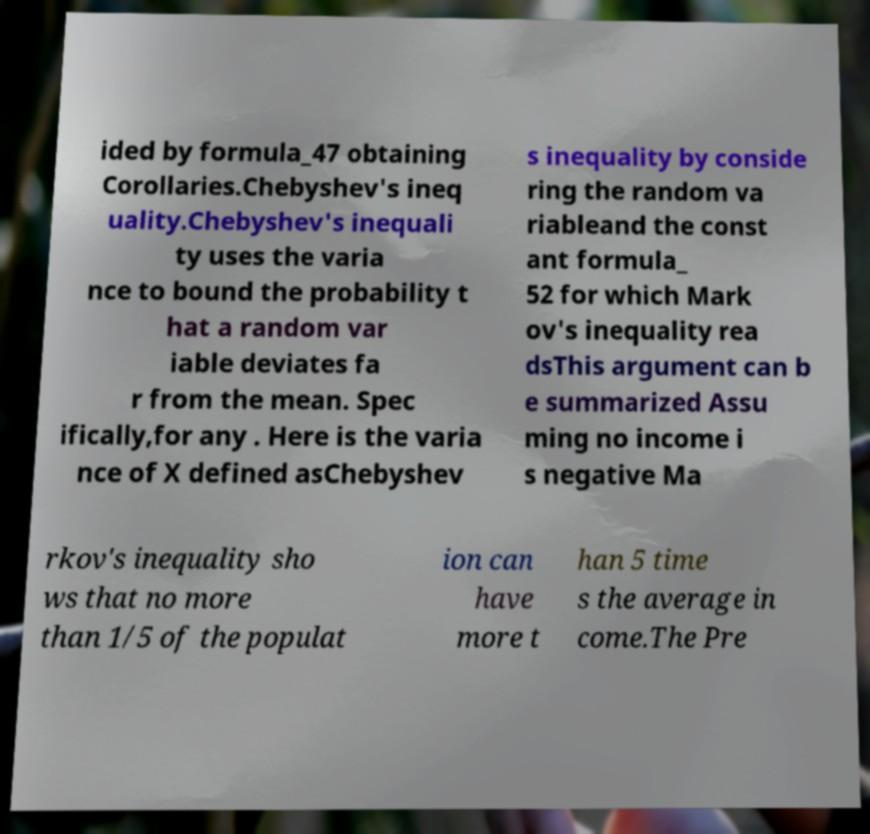For documentation purposes, I need the text within this image transcribed. Could you provide that? ided by formula_47 obtaining Corollaries.Chebyshev's ineq uality.Chebyshev's inequali ty uses the varia nce to bound the probability t hat a random var iable deviates fa r from the mean. Spec ifically,for any . Here is the varia nce of X defined asChebyshev s inequality by conside ring the random va riableand the const ant formula_ 52 for which Mark ov's inequality rea dsThis argument can b e summarized Assu ming no income i s negative Ma rkov's inequality sho ws that no more than 1/5 of the populat ion can have more t han 5 time s the average in come.The Pre 